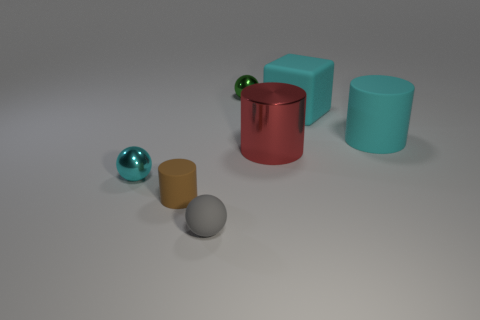Subtract all tiny shiny balls. How many balls are left? 1 Add 1 tiny green shiny things. How many objects exist? 8 Subtract 2 cylinders. How many cylinders are left? 1 Subtract all brown cylinders. How many cylinders are left? 2 Subtract all blocks. How many objects are left? 6 Subtract all purple balls. Subtract all gray cylinders. How many balls are left? 3 Subtract all cyan blocks. How many gray cylinders are left? 0 Subtract all large yellow matte cylinders. Subtract all big cylinders. How many objects are left? 5 Add 3 small brown matte cylinders. How many small brown matte cylinders are left? 4 Add 4 blue cylinders. How many blue cylinders exist? 4 